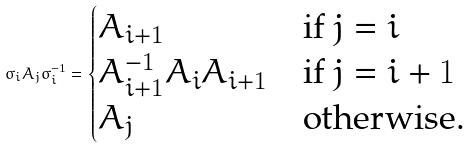<formula> <loc_0><loc_0><loc_500><loc_500>\sigma _ { i } A _ { j } \sigma _ { i } ^ { - 1 } = \begin{cases} A _ { i + 1 } & \text {if $j=i$} \\ A _ { i + 1 } ^ { - 1 } A _ { i } A _ { i + 1 } & \text {if $j=i+1$} \\ A _ { j } & \text {otherwise.} \\ \end{cases}</formula> 